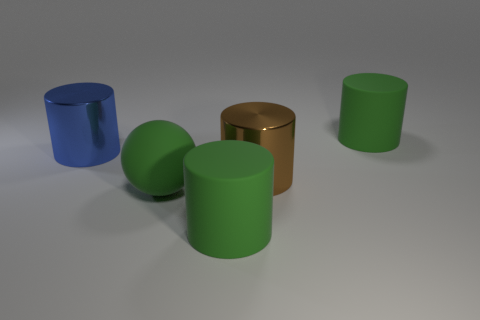Are there fewer blue things than large metallic cylinders?
Offer a terse response. Yes. There is a blue thing that is the same size as the brown cylinder; what is its material?
Offer a very short reply. Metal. There is a matte object in front of the large matte ball; is its size the same as the thing that is to the left of the big green sphere?
Ensure brevity in your answer.  Yes. Are there any other large things made of the same material as the blue thing?
Offer a terse response. Yes. How many things are either matte things that are to the right of the brown metallic cylinder or large blue rubber cubes?
Keep it short and to the point. 1. Are the big object behind the blue metallic cylinder and the large brown cylinder made of the same material?
Keep it short and to the point. No. Is the shape of the blue metal object the same as the brown object?
Provide a succinct answer. Yes. How many brown shiny cylinders are on the right side of the big object to the right of the big brown cylinder?
Your answer should be very brief. 0. There is a large blue object that is the same shape as the brown thing; what material is it?
Provide a succinct answer. Metal. Is the color of the big thing in front of the sphere the same as the big matte ball?
Offer a very short reply. Yes. 